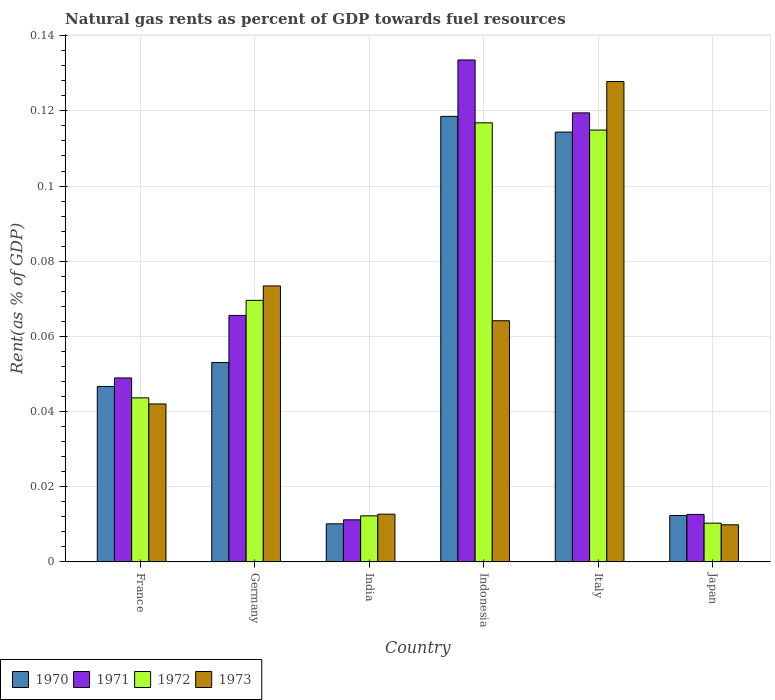How many different coloured bars are there?
Offer a terse response. 4. How many bars are there on the 6th tick from the left?
Your answer should be very brief. 4. How many bars are there on the 3rd tick from the right?
Your answer should be very brief. 4. What is the label of the 6th group of bars from the left?
Your answer should be compact. Japan. In how many cases, is the number of bars for a given country not equal to the number of legend labels?
Give a very brief answer. 0. What is the matural gas rent in 1970 in Germany?
Offer a very short reply. 0.05. Across all countries, what is the maximum matural gas rent in 1972?
Provide a succinct answer. 0.12. Across all countries, what is the minimum matural gas rent in 1971?
Your answer should be very brief. 0.01. What is the total matural gas rent in 1972 in the graph?
Offer a very short reply. 0.37. What is the difference between the matural gas rent in 1970 in India and that in Indonesia?
Provide a succinct answer. -0.11. What is the difference between the matural gas rent in 1972 in India and the matural gas rent in 1971 in Japan?
Your answer should be very brief. -0. What is the average matural gas rent in 1970 per country?
Your answer should be very brief. 0.06. What is the difference between the matural gas rent of/in 1971 and matural gas rent of/in 1973 in Germany?
Offer a very short reply. -0.01. In how many countries, is the matural gas rent in 1971 greater than 0.096 %?
Provide a succinct answer. 2. What is the ratio of the matural gas rent in 1972 in Germany to that in Italy?
Your answer should be very brief. 0.61. What is the difference between the highest and the second highest matural gas rent in 1971?
Provide a succinct answer. 0.07. What is the difference between the highest and the lowest matural gas rent in 1971?
Ensure brevity in your answer.  0.12. In how many countries, is the matural gas rent in 1972 greater than the average matural gas rent in 1972 taken over all countries?
Your answer should be compact. 3. Is the sum of the matural gas rent in 1970 in France and India greater than the maximum matural gas rent in 1971 across all countries?
Provide a short and direct response. No. What does the 4th bar from the right in India represents?
Make the answer very short. 1970. Is it the case that in every country, the sum of the matural gas rent in 1970 and matural gas rent in 1972 is greater than the matural gas rent in 1973?
Offer a terse response. Yes. How many bars are there?
Your response must be concise. 24. How many legend labels are there?
Your answer should be very brief. 4. How are the legend labels stacked?
Make the answer very short. Horizontal. What is the title of the graph?
Provide a succinct answer. Natural gas rents as percent of GDP towards fuel resources. What is the label or title of the X-axis?
Provide a short and direct response. Country. What is the label or title of the Y-axis?
Your answer should be compact. Rent(as % of GDP). What is the Rent(as % of GDP) of 1970 in France?
Offer a very short reply. 0.05. What is the Rent(as % of GDP) of 1971 in France?
Give a very brief answer. 0.05. What is the Rent(as % of GDP) in 1972 in France?
Keep it short and to the point. 0.04. What is the Rent(as % of GDP) in 1973 in France?
Ensure brevity in your answer.  0.04. What is the Rent(as % of GDP) of 1970 in Germany?
Give a very brief answer. 0.05. What is the Rent(as % of GDP) of 1971 in Germany?
Provide a short and direct response. 0.07. What is the Rent(as % of GDP) in 1972 in Germany?
Give a very brief answer. 0.07. What is the Rent(as % of GDP) in 1973 in Germany?
Offer a very short reply. 0.07. What is the Rent(as % of GDP) of 1970 in India?
Give a very brief answer. 0.01. What is the Rent(as % of GDP) of 1971 in India?
Provide a succinct answer. 0.01. What is the Rent(as % of GDP) in 1972 in India?
Make the answer very short. 0.01. What is the Rent(as % of GDP) in 1973 in India?
Your answer should be compact. 0.01. What is the Rent(as % of GDP) in 1970 in Indonesia?
Ensure brevity in your answer.  0.12. What is the Rent(as % of GDP) of 1971 in Indonesia?
Make the answer very short. 0.13. What is the Rent(as % of GDP) in 1972 in Indonesia?
Offer a very short reply. 0.12. What is the Rent(as % of GDP) of 1973 in Indonesia?
Ensure brevity in your answer.  0.06. What is the Rent(as % of GDP) in 1970 in Italy?
Ensure brevity in your answer.  0.11. What is the Rent(as % of GDP) of 1971 in Italy?
Keep it short and to the point. 0.12. What is the Rent(as % of GDP) in 1972 in Italy?
Provide a short and direct response. 0.11. What is the Rent(as % of GDP) of 1973 in Italy?
Provide a short and direct response. 0.13. What is the Rent(as % of GDP) in 1970 in Japan?
Provide a short and direct response. 0.01. What is the Rent(as % of GDP) in 1971 in Japan?
Make the answer very short. 0.01. What is the Rent(as % of GDP) of 1972 in Japan?
Your answer should be very brief. 0.01. What is the Rent(as % of GDP) in 1973 in Japan?
Your response must be concise. 0.01. Across all countries, what is the maximum Rent(as % of GDP) of 1970?
Provide a short and direct response. 0.12. Across all countries, what is the maximum Rent(as % of GDP) of 1971?
Your response must be concise. 0.13. Across all countries, what is the maximum Rent(as % of GDP) of 1972?
Provide a short and direct response. 0.12. Across all countries, what is the maximum Rent(as % of GDP) of 1973?
Provide a succinct answer. 0.13. Across all countries, what is the minimum Rent(as % of GDP) of 1970?
Ensure brevity in your answer.  0.01. Across all countries, what is the minimum Rent(as % of GDP) of 1971?
Keep it short and to the point. 0.01. Across all countries, what is the minimum Rent(as % of GDP) in 1972?
Keep it short and to the point. 0.01. Across all countries, what is the minimum Rent(as % of GDP) in 1973?
Give a very brief answer. 0.01. What is the total Rent(as % of GDP) in 1970 in the graph?
Your answer should be very brief. 0.36. What is the total Rent(as % of GDP) in 1971 in the graph?
Provide a succinct answer. 0.39. What is the total Rent(as % of GDP) of 1972 in the graph?
Keep it short and to the point. 0.37. What is the total Rent(as % of GDP) in 1973 in the graph?
Provide a short and direct response. 0.33. What is the difference between the Rent(as % of GDP) of 1970 in France and that in Germany?
Keep it short and to the point. -0.01. What is the difference between the Rent(as % of GDP) in 1971 in France and that in Germany?
Give a very brief answer. -0.02. What is the difference between the Rent(as % of GDP) in 1972 in France and that in Germany?
Provide a succinct answer. -0.03. What is the difference between the Rent(as % of GDP) in 1973 in France and that in Germany?
Provide a short and direct response. -0.03. What is the difference between the Rent(as % of GDP) in 1970 in France and that in India?
Your answer should be very brief. 0.04. What is the difference between the Rent(as % of GDP) in 1971 in France and that in India?
Give a very brief answer. 0.04. What is the difference between the Rent(as % of GDP) of 1972 in France and that in India?
Your answer should be compact. 0.03. What is the difference between the Rent(as % of GDP) in 1973 in France and that in India?
Your response must be concise. 0.03. What is the difference between the Rent(as % of GDP) of 1970 in France and that in Indonesia?
Keep it short and to the point. -0.07. What is the difference between the Rent(as % of GDP) in 1971 in France and that in Indonesia?
Offer a very short reply. -0.08. What is the difference between the Rent(as % of GDP) in 1972 in France and that in Indonesia?
Your answer should be very brief. -0.07. What is the difference between the Rent(as % of GDP) of 1973 in France and that in Indonesia?
Offer a very short reply. -0.02. What is the difference between the Rent(as % of GDP) in 1970 in France and that in Italy?
Offer a terse response. -0.07. What is the difference between the Rent(as % of GDP) of 1971 in France and that in Italy?
Ensure brevity in your answer.  -0.07. What is the difference between the Rent(as % of GDP) of 1972 in France and that in Italy?
Keep it short and to the point. -0.07. What is the difference between the Rent(as % of GDP) in 1973 in France and that in Italy?
Keep it short and to the point. -0.09. What is the difference between the Rent(as % of GDP) of 1970 in France and that in Japan?
Your answer should be very brief. 0.03. What is the difference between the Rent(as % of GDP) of 1971 in France and that in Japan?
Your answer should be very brief. 0.04. What is the difference between the Rent(as % of GDP) in 1973 in France and that in Japan?
Offer a terse response. 0.03. What is the difference between the Rent(as % of GDP) in 1970 in Germany and that in India?
Give a very brief answer. 0.04. What is the difference between the Rent(as % of GDP) of 1971 in Germany and that in India?
Provide a succinct answer. 0.05. What is the difference between the Rent(as % of GDP) in 1972 in Germany and that in India?
Keep it short and to the point. 0.06. What is the difference between the Rent(as % of GDP) of 1973 in Germany and that in India?
Keep it short and to the point. 0.06. What is the difference between the Rent(as % of GDP) in 1970 in Germany and that in Indonesia?
Ensure brevity in your answer.  -0.07. What is the difference between the Rent(as % of GDP) of 1971 in Germany and that in Indonesia?
Ensure brevity in your answer.  -0.07. What is the difference between the Rent(as % of GDP) of 1972 in Germany and that in Indonesia?
Offer a terse response. -0.05. What is the difference between the Rent(as % of GDP) in 1973 in Germany and that in Indonesia?
Provide a short and direct response. 0.01. What is the difference between the Rent(as % of GDP) in 1970 in Germany and that in Italy?
Provide a succinct answer. -0.06. What is the difference between the Rent(as % of GDP) of 1971 in Germany and that in Italy?
Offer a very short reply. -0.05. What is the difference between the Rent(as % of GDP) in 1972 in Germany and that in Italy?
Keep it short and to the point. -0.05. What is the difference between the Rent(as % of GDP) of 1973 in Germany and that in Italy?
Make the answer very short. -0.05. What is the difference between the Rent(as % of GDP) in 1970 in Germany and that in Japan?
Provide a succinct answer. 0.04. What is the difference between the Rent(as % of GDP) in 1971 in Germany and that in Japan?
Your answer should be very brief. 0.05. What is the difference between the Rent(as % of GDP) in 1972 in Germany and that in Japan?
Ensure brevity in your answer.  0.06. What is the difference between the Rent(as % of GDP) in 1973 in Germany and that in Japan?
Provide a short and direct response. 0.06. What is the difference between the Rent(as % of GDP) of 1970 in India and that in Indonesia?
Make the answer very short. -0.11. What is the difference between the Rent(as % of GDP) of 1971 in India and that in Indonesia?
Ensure brevity in your answer.  -0.12. What is the difference between the Rent(as % of GDP) of 1972 in India and that in Indonesia?
Keep it short and to the point. -0.1. What is the difference between the Rent(as % of GDP) in 1973 in India and that in Indonesia?
Ensure brevity in your answer.  -0.05. What is the difference between the Rent(as % of GDP) of 1970 in India and that in Italy?
Your response must be concise. -0.1. What is the difference between the Rent(as % of GDP) of 1971 in India and that in Italy?
Keep it short and to the point. -0.11. What is the difference between the Rent(as % of GDP) in 1972 in India and that in Italy?
Offer a very short reply. -0.1. What is the difference between the Rent(as % of GDP) in 1973 in India and that in Italy?
Your response must be concise. -0.12. What is the difference between the Rent(as % of GDP) in 1970 in India and that in Japan?
Your answer should be compact. -0. What is the difference between the Rent(as % of GDP) of 1971 in India and that in Japan?
Provide a short and direct response. -0. What is the difference between the Rent(as % of GDP) of 1972 in India and that in Japan?
Your answer should be compact. 0. What is the difference between the Rent(as % of GDP) of 1973 in India and that in Japan?
Make the answer very short. 0. What is the difference between the Rent(as % of GDP) of 1970 in Indonesia and that in Italy?
Keep it short and to the point. 0. What is the difference between the Rent(as % of GDP) of 1971 in Indonesia and that in Italy?
Your response must be concise. 0.01. What is the difference between the Rent(as % of GDP) of 1972 in Indonesia and that in Italy?
Ensure brevity in your answer.  0. What is the difference between the Rent(as % of GDP) in 1973 in Indonesia and that in Italy?
Give a very brief answer. -0.06. What is the difference between the Rent(as % of GDP) in 1970 in Indonesia and that in Japan?
Your answer should be very brief. 0.11. What is the difference between the Rent(as % of GDP) in 1971 in Indonesia and that in Japan?
Ensure brevity in your answer.  0.12. What is the difference between the Rent(as % of GDP) of 1972 in Indonesia and that in Japan?
Offer a very short reply. 0.11. What is the difference between the Rent(as % of GDP) in 1973 in Indonesia and that in Japan?
Give a very brief answer. 0.05. What is the difference between the Rent(as % of GDP) in 1970 in Italy and that in Japan?
Ensure brevity in your answer.  0.1. What is the difference between the Rent(as % of GDP) in 1971 in Italy and that in Japan?
Ensure brevity in your answer.  0.11. What is the difference between the Rent(as % of GDP) in 1972 in Italy and that in Japan?
Ensure brevity in your answer.  0.1. What is the difference between the Rent(as % of GDP) in 1973 in Italy and that in Japan?
Keep it short and to the point. 0.12. What is the difference between the Rent(as % of GDP) in 1970 in France and the Rent(as % of GDP) in 1971 in Germany?
Ensure brevity in your answer.  -0.02. What is the difference between the Rent(as % of GDP) of 1970 in France and the Rent(as % of GDP) of 1972 in Germany?
Ensure brevity in your answer.  -0.02. What is the difference between the Rent(as % of GDP) of 1970 in France and the Rent(as % of GDP) of 1973 in Germany?
Your answer should be compact. -0.03. What is the difference between the Rent(as % of GDP) of 1971 in France and the Rent(as % of GDP) of 1972 in Germany?
Give a very brief answer. -0.02. What is the difference between the Rent(as % of GDP) in 1971 in France and the Rent(as % of GDP) in 1973 in Germany?
Keep it short and to the point. -0.02. What is the difference between the Rent(as % of GDP) of 1972 in France and the Rent(as % of GDP) of 1973 in Germany?
Offer a terse response. -0.03. What is the difference between the Rent(as % of GDP) of 1970 in France and the Rent(as % of GDP) of 1971 in India?
Keep it short and to the point. 0.04. What is the difference between the Rent(as % of GDP) in 1970 in France and the Rent(as % of GDP) in 1972 in India?
Give a very brief answer. 0.03. What is the difference between the Rent(as % of GDP) in 1970 in France and the Rent(as % of GDP) in 1973 in India?
Your response must be concise. 0.03. What is the difference between the Rent(as % of GDP) in 1971 in France and the Rent(as % of GDP) in 1972 in India?
Your response must be concise. 0.04. What is the difference between the Rent(as % of GDP) in 1971 in France and the Rent(as % of GDP) in 1973 in India?
Make the answer very short. 0.04. What is the difference between the Rent(as % of GDP) of 1972 in France and the Rent(as % of GDP) of 1973 in India?
Offer a terse response. 0.03. What is the difference between the Rent(as % of GDP) in 1970 in France and the Rent(as % of GDP) in 1971 in Indonesia?
Make the answer very short. -0.09. What is the difference between the Rent(as % of GDP) in 1970 in France and the Rent(as % of GDP) in 1972 in Indonesia?
Offer a terse response. -0.07. What is the difference between the Rent(as % of GDP) of 1970 in France and the Rent(as % of GDP) of 1973 in Indonesia?
Offer a very short reply. -0.02. What is the difference between the Rent(as % of GDP) of 1971 in France and the Rent(as % of GDP) of 1972 in Indonesia?
Provide a succinct answer. -0.07. What is the difference between the Rent(as % of GDP) in 1971 in France and the Rent(as % of GDP) in 1973 in Indonesia?
Offer a very short reply. -0.02. What is the difference between the Rent(as % of GDP) in 1972 in France and the Rent(as % of GDP) in 1973 in Indonesia?
Give a very brief answer. -0.02. What is the difference between the Rent(as % of GDP) in 1970 in France and the Rent(as % of GDP) in 1971 in Italy?
Give a very brief answer. -0.07. What is the difference between the Rent(as % of GDP) in 1970 in France and the Rent(as % of GDP) in 1972 in Italy?
Give a very brief answer. -0.07. What is the difference between the Rent(as % of GDP) in 1970 in France and the Rent(as % of GDP) in 1973 in Italy?
Offer a terse response. -0.08. What is the difference between the Rent(as % of GDP) in 1971 in France and the Rent(as % of GDP) in 1972 in Italy?
Make the answer very short. -0.07. What is the difference between the Rent(as % of GDP) of 1971 in France and the Rent(as % of GDP) of 1973 in Italy?
Ensure brevity in your answer.  -0.08. What is the difference between the Rent(as % of GDP) of 1972 in France and the Rent(as % of GDP) of 1973 in Italy?
Provide a short and direct response. -0.08. What is the difference between the Rent(as % of GDP) in 1970 in France and the Rent(as % of GDP) in 1971 in Japan?
Your answer should be compact. 0.03. What is the difference between the Rent(as % of GDP) of 1970 in France and the Rent(as % of GDP) of 1972 in Japan?
Offer a terse response. 0.04. What is the difference between the Rent(as % of GDP) in 1970 in France and the Rent(as % of GDP) in 1973 in Japan?
Provide a short and direct response. 0.04. What is the difference between the Rent(as % of GDP) of 1971 in France and the Rent(as % of GDP) of 1972 in Japan?
Offer a terse response. 0.04. What is the difference between the Rent(as % of GDP) of 1971 in France and the Rent(as % of GDP) of 1973 in Japan?
Provide a succinct answer. 0.04. What is the difference between the Rent(as % of GDP) in 1972 in France and the Rent(as % of GDP) in 1973 in Japan?
Your answer should be compact. 0.03. What is the difference between the Rent(as % of GDP) of 1970 in Germany and the Rent(as % of GDP) of 1971 in India?
Your answer should be very brief. 0.04. What is the difference between the Rent(as % of GDP) of 1970 in Germany and the Rent(as % of GDP) of 1972 in India?
Offer a very short reply. 0.04. What is the difference between the Rent(as % of GDP) of 1970 in Germany and the Rent(as % of GDP) of 1973 in India?
Offer a terse response. 0.04. What is the difference between the Rent(as % of GDP) in 1971 in Germany and the Rent(as % of GDP) in 1972 in India?
Your answer should be compact. 0.05. What is the difference between the Rent(as % of GDP) in 1971 in Germany and the Rent(as % of GDP) in 1973 in India?
Ensure brevity in your answer.  0.05. What is the difference between the Rent(as % of GDP) in 1972 in Germany and the Rent(as % of GDP) in 1973 in India?
Give a very brief answer. 0.06. What is the difference between the Rent(as % of GDP) of 1970 in Germany and the Rent(as % of GDP) of 1971 in Indonesia?
Your answer should be very brief. -0.08. What is the difference between the Rent(as % of GDP) of 1970 in Germany and the Rent(as % of GDP) of 1972 in Indonesia?
Your answer should be very brief. -0.06. What is the difference between the Rent(as % of GDP) in 1970 in Germany and the Rent(as % of GDP) in 1973 in Indonesia?
Your answer should be very brief. -0.01. What is the difference between the Rent(as % of GDP) in 1971 in Germany and the Rent(as % of GDP) in 1972 in Indonesia?
Your response must be concise. -0.05. What is the difference between the Rent(as % of GDP) of 1971 in Germany and the Rent(as % of GDP) of 1973 in Indonesia?
Make the answer very short. 0. What is the difference between the Rent(as % of GDP) in 1972 in Germany and the Rent(as % of GDP) in 1973 in Indonesia?
Provide a succinct answer. 0.01. What is the difference between the Rent(as % of GDP) of 1970 in Germany and the Rent(as % of GDP) of 1971 in Italy?
Offer a very short reply. -0.07. What is the difference between the Rent(as % of GDP) of 1970 in Germany and the Rent(as % of GDP) of 1972 in Italy?
Provide a succinct answer. -0.06. What is the difference between the Rent(as % of GDP) in 1970 in Germany and the Rent(as % of GDP) in 1973 in Italy?
Offer a terse response. -0.07. What is the difference between the Rent(as % of GDP) of 1971 in Germany and the Rent(as % of GDP) of 1972 in Italy?
Provide a succinct answer. -0.05. What is the difference between the Rent(as % of GDP) in 1971 in Germany and the Rent(as % of GDP) in 1973 in Italy?
Give a very brief answer. -0.06. What is the difference between the Rent(as % of GDP) in 1972 in Germany and the Rent(as % of GDP) in 1973 in Italy?
Keep it short and to the point. -0.06. What is the difference between the Rent(as % of GDP) in 1970 in Germany and the Rent(as % of GDP) in 1971 in Japan?
Your answer should be compact. 0.04. What is the difference between the Rent(as % of GDP) of 1970 in Germany and the Rent(as % of GDP) of 1972 in Japan?
Offer a very short reply. 0.04. What is the difference between the Rent(as % of GDP) in 1970 in Germany and the Rent(as % of GDP) in 1973 in Japan?
Provide a short and direct response. 0.04. What is the difference between the Rent(as % of GDP) of 1971 in Germany and the Rent(as % of GDP) of 1972 in Japan?
Your response must be concise. 0.06. What is the difference between the Rent(as % of GDP) in 1971 in Germany and the Rent(as % of GDP) in 1973 in Japan?
Keep it short and to the point. 0.06. What is the difference between the Rent(as % of GDP) in 1972 in Germany and the Rent(as % of GDP) in 1973 in Japan?
Offer a very short reply. 0.06. What is the difference between the Rent(as % of GDP) of 1970 in India and the Rent(as % of GDP) of 1971 in Indonesia?
Keep it short and to the point. -0.12. What is the difference between the Rent(as % of GDP) in 1970 in India and the Rent(as % of GDP) in 1972 in Indonesia?
Your response must be concise. -0.11. What is the difference between the Rent(as % of GDP) of 1970 in India and the Rent(as % of GDP) of 1973 in Indonesia?
Ensure brevity in your answer.  -0.05. What is the difference between the Rent(as % of GDP) in 1971 in India and the Rent(as % of GDP) in 1972 in Indonesia?
Provide a succinct answer. -0.11. What is the difference between the Rent(as % of GDP) of 1971 in India and the Rent(as % of GDP) of 1973 in Indonesia?
Your answer should be very brief. -0.05. What is the difference between the Rent(as % of GDP) in 1972 in India and the Rent(as % of GDP) in 1973 in Indonesia?
Offer a terse response. -0.05. What is the difference between the Rent(as % of GDP) of 1970 in India and the Rent(as % of GDP) of 1971 in Italy?
Keep it short and to the point. -0.11. What is the difference between the Rent(as % of GDP) in 1970 in India and the Rent(as % of GDP) in 1972 in Italy?
Make the answer very short. -0.1. What is the difference between the Rent(as % of GDP) of 1970 in India and the Rent(as % of GDP) of 1973 in Italy?
Offer a very short reply. -0.12. What is the difference between the Rent(as % of GDP) in 1971 in India and the Rent(as % of GDP) in 1972 in Italy?
Your answer should be compact. -0.1. What is the difference between the Rent(as % of GDP) of 1971 in India and the Rent(as % of GDP) of 1973 in Italy?
Make the answer very short. -0.12. What is the difference between the Rent(as % of GDP) in 1972 in India and the Rent(as % of GDP) in 1973 in Italy?
Your answer should be very brief. -0.12. What is the difference between the Rent(as % of GDP) in 1970 in India and the Rent(as % of GDP) in 1971 in Japan?
Provide a succinct answer. -0. What is the difference between the Rent(as % of GDP) in 1970 in India and the Rent(as % of GDP) in 1972 in Japan?
Give a very brief answer. -0. What is the difference between the Rent(as % of GDP) of 1970 in India and the Rent(as % of GDP) of 1973 in Japan?
Provide a short and direct response. 0. What is the difference between the Rent(as % of GDP) in 1971 in India and the Rent(as % of GDP) in 1972 in Japan?
Your response must be concise. 0. What is the difference between the Rent(as % of GDP) of 1971 in India and the Rent(as % of GDP) of 1973 in Japan?
Offer a very short reply. 0. What is the difference between the Rent(as % of GDP) in 1972 in India and the Rent(as % of GDP) in 1973 in Japan?
Offer a terse response. 0. What is the difference between the Rent(as % of GDP) in 1970 in Indonesia and the Rent(as % of GDP) in 1971 in Italy?
Your response must be concise. -0. What is the difference between the Rent(as % of GDP) of 1970 in Indonesia and the Rent(as % of GDP) of 1972 in Italy?
Provide a succinct answer. 0. What is the difference between the Rent(as % of GDP) in 1970 in Indonesia and the Rent(as % of GDP) in 1973 in Italy?
Offer a very short reply. -0.01. What is the difference between the Rent(as % of GDP) in 1971 in Indonesia and the Rent(as % of GDP) in 1972 in Italy?
Keep it short and to the point. 0.02. What is the difference between the Rent(as % of GDP) of 1971 in Indonesia and the Rent(as % of GDP) of 1973 in Italy?
Your response must be concise. 0.01. What is the difference between the Rent(as % of GDP) of 1972 in Indonesia and the Rent(as % of GDP) of 1973 in Italy?
Provide a succinct answer. -0.01. What is the difference between the Rent(as % of GDP) of 1970 in Indonesia and the Rent(as % of GDP) of 1971 in Japan?
Provide a short and direct response. 0.11. What is the difference between the Rent(as % of GDP) of 1970 in Indonesia and the Rent(as % of GDP) of 1972 in Japan?
Offer a very short reply. 0.11. What is the difference between the Rent(as % of GDP) in 1970 in Indonesia and the Rent(as % of GDP) in 1973 in Japan?
Offer a terse response. 0.11. What is the difference between the Rent(as % of GDP) in 1971 in Indonesia and the Rent(as % of GDP) in 1972 in Japan?
Provide a short and direct response. 0.12. What is the difference between the Rent(as % of GDP) in 1971 in Indonesia and the Rent(as % of GDP) in 1973 in Japan?
Your response must be concise. 0.12. What is the difference between the Rent(as % of GDP) in 1972 in Indonesia and the Rent(as % of GDP) in 1973 in Japan?
Offer a very short reply. 0.11. What is the difference between the Rent(as % of GDP) in 1970 in Italy and the Rent(as % of GDP) in 1971 in Japan?
Keep it short and to the point. 0.1. What is the difference between the Rent(as % of GDP) in 1970 in Italy and the Rent(as % of GDP) in 1972 in Japan?
Make the answer very short. 0.1. What is the difference between the Rent(as % of GDP) of 1970 in Italy and the Rent(as % of GDP) of 1973 in Japan?
Make the answer very short. 0.1. What is the difference between the Rent(as % of GDP) in 1971 in Italy and the Rent(as % of GDP) in 1972 in Japan?
Offer a very short reply. 0.11. What is the difference between the Rent(as % of GDP) of 1971 in Italy and the Rent(as % of GDP) of 1973 in Japan?
Ensure brevity in your answer.  0.11. What is the difference between the Rent(as % of GDP) of 1972 in Italy and the Rent(as % of GDP) of 1973 in Japan?
Make the answer very short. 0.1. What is the average Rent(as % of GDP) of 1970 per country?
Keep it short and to the point. 0.06. What is the average Rent(as % of GDP) in 1971 per country?
Offer a very short reply. 0.07. What is the average Rent(as % of GDP) of 1972 per country?
Provide a short and direct response. 0.06. What is the average Rent(as % of GDP) of 1973 per country?
Provide a short and direct response. 0.06. What is the difference between the Rent(as % of GDP) in 1970 and Rent(as % of GDP) in 1971 in France?
Keep it short and to the point. -0. What is the difference between the Rent(as % of GDP) in 1970 and Rent(as % of GDP) in 1972 in France?
Provide a short and direct response. 0. What is the difference between the Rent(as % of GDP) of 1970 and Rent(as % of GDP) of 1973 in France?
Your answer should be very brief. 0. What is the difference between the Rent(as % of GDP) of 1971 and Rent(as % of GDP) of 1972 in France?
Offer a terse response. 0.01. What is the difference between the Rent(as % of GDP) in 1971 and Rent(as % of GDP) in 1973 in France?
Your answer should be very brief. 0.01. What is the difference between the Rent(as % of GDP) of 1972 and Rent(as % of GDP) of 1973 in France?
Ensure brevity in your answer.  0. What is the difference between the Rent(as % of GDP) of 1970 and Rent(as % of GDP) of 1971 in Germany?
Ensure brevity in your answer.  -0.01. What is the difference between the Rent(as % of GDP) of 1970 and Rent(as % of GDP) of 1972 in Germany?
Offer a very short reply. -0.02. What is the difference between the Rent(as % of GDP) of 1970 and Rent(as % of GDP) of 1973 in Germany?
Offer a terse response. -0.02. What is the difference between the Rent(as % of GDP) of 1971 and Rent(as % of GDP) of 1972 in Germany?
Keep it short and to the point. -0. What is the difference between the Rent(as % of GDP) of 1971 and Rent(as % of GDP) of 1973 in Germany?
Offer a very short reply. -0.01. What is the difference between the Rent(as % of GDP) in 1972 and Rent(as % of GDP) in 1973 in Germany?
Your answer should be compact. -0. What is the difference between the Rent(as % of GDP) of 1970 and Rent(as % of GDP) of 1971 in India?
Provide a short and direct response. -0. What is the difference between the Rent(as % of GDP) of 1970 and Rent(as % of GDP) of 1972 in India?
Offer a very short reply. -0. What is the difference between the Rent(as % of GDP) of 1970 and Rent(as % of GDP) of 1973 in India?
Provide a short and direct response. -0. What is the difference between the Rent(as % of GDP) in 1971 and Rent(as % of GDP) in 1972 in India?
Your answer should be compact. -0. What is the difference between the Rent(as % of GDP) of 1971 and Rent(as % of GDP) of 1973 in India?
Your answer should be very brief. -0. What is the difference between the Rent(as % of GDP) in 1972 and Rent(as % of GDP) in 1973 in India?
Offer a terse response. -0. What is the difference between the Rent(as % of GDP) of 1970 and Rent(as % of GDP) of 1971 in Indonesia?
Your answer should be compact. -0.01. What is the difference between the Rent(as % of GDP) of 1970 and Rent(as % of GDP) of 1972 in Indonesia?
Give a very brief answer. 0. What is the difference between the Rent(as % of GDP) of 1970 and Rent(as % of GDP) of 1973 in Indonesia?
Make the answer very short. 0.05. What is the difference between the Rent(as % of GDP) of 1971 and Rent(as % of GDP) of 1972 in Indonesia?
Your response must be concise. 0.02. What is the difference between the Rent(as % of GDP) in 1971 and Rent(as % of GDP) in 1973 in Indonesia?
Your answer should be very brief. 0.07. What is the difference between the Rent(as % of GDP) of 1972 and Rent(as % of GDP) of 1973 in Indonesia?
Your answer should be compact. 0.05. What is the difference between the Rent(as % of GDP) of 1970 and Rent(as % of GDP) of 1971 in Italy?
Keep it short and to the point. -0.01. What is the difference between the Rent(as % of GDP) of 1970 and Rent(as % of GDP) of 1972 in Italy?
Provide a succinct answer. -0. What is the difference between the Rent(as % of GDP) in 1970 and Rent(as % of GDP) in 1973 in Italy?
Offer a very short reply. -0.01. What is the difference between the Rent(as % of GDP) in 1971 and Rent(as % of GDP) in 1972 in Italy?
Your response must be concise. 0. What is the difference between the Rent(as % of GDP) in 1971 and Rent(as % of GDP) in 1973 in Italy?
Provide a succinct answer. -0.01. What is the difference between the Rent(as % of GDP) in 1972 and Rent(as % of GDP) in 1973 in Italy?
Your answer should be compact. -0.01. What is the difference between the Rent(as % of GDP) in 1970 and Rent(as % of GDP) in 1971 in Japan?
Ensure brevity in your answer.  -0. What is the difference between the Rent(as % of GDP) in 1970 and Rent(as % of GDP) in 1972 in Japan?
Provide a succinct answer. 0. What is the difference between the Rent(as % of GDP) in 1970 and Rent(as % of GDP) in 1973 in Japan?
Give a very brief answer. 0. What is the difference between the Rent(as % of GDP) of 1971 and Rent(as % of GDP) of 1972 in Japan?
Your answer should be compact. 0. What is the difference between the Rent(as % of GDP) of 1971 and Rent(as % of GDP) of 1973 in Japan?
Give a very brief answer. 0. What is the difference between the Rent(as % of GDP) in 1972 and Rent(as % of GDP) in 1973 in Japan?
Make the answer very short. 0. What is the ratio of the Rent(as % of GDP) in 1970 in France to that in Germany?
Keep it short and to the point. 0.88. What is the ratio of the Rent(as % of GDP) of 1971 in France to that in Germany?
Make the answer very short. 0.75. What is the ratio of the Rent(as % of GDP) in 1972 in France to that in Germany?
Make the answer very short. 0.63. What is the ratio of the Rent(as % of GDP) of 1973 in France to that in Germany?
Ensure brevity in your answer.  0.57. What is the ratio of the Rent(as % of GDP) in 1970 in France to that in India?
Keep it short and to the point. 4.61. What is the ratio of the Rent(as % of GDP) in 1971 in France to that in India?
Offer a terse response. 4.37. What is the ratio of the Rent(as % of GDP) in 1972 in France to that in India?
Your answer should be compact. 3.56. What is the ratio of the Rent(as % of GDP) in 1973 in France to that in India?
Offer a very short reply. 3.31. What is the ratio of the Rent(as % of GDP) in 1970 in France to that in Indonesia?
Give a very brief answer. 0.39. What is the ratio of the Rent(as % of GDP) in 1971 in France to that in Indonesia?
Give a very brief answer. 0.37. What is the ratio of the Rent(as % of GDP) in 1972 in France to that in Indonesia?
Your response must be concise. 0.37. What is the ratio of the Rent(as % of GDP) in 1973 in France to that in Indonesia?
Your response must be concise. 0.65. What is the ratio of the Rent(as % of GDP) in 1970 in France to that in Italy?
Keep it short and to the point. 0.41. What is the ratio of the Rent(as % of GDP) of 1971 in France to that in Italy?
Ensure brevity in your answer.  0.41. What is the ratio of the Rent(as % of GDP) of 1972 in France to that in Italy?
Provide a succinct answer. 0.38. What is the ratio of the Rent(as % of GDP) in 1973 in France to that in Italy?
Provide a short and direct response. 0.33. What is the ratio of the Rent(as % of GDP) of 1970 in France to that in Japan?
Offer a very short reply. 3.78. What is the ratio of the Rent(as % of GDP) in 1971 in France to that in Japan?
Your answer should be very brief. 3.88. What is the ratio of the Rent(as % of GDP) in 1972 in France to that in Japan?
Offer a very short reply. 4.24. What is the ratio of the Rent(as % of GDP) of 1973 in France to that in Japan?
Provide a short and direct response. 4.26. What is the ratio of the Rent(as % of GDP) in 1970 in Germany to that in India?
Offer a terse response. 5.24. What is the ratio of the Rent(as % of GDP) in 1971 in Germany to that in India?
Your answer should be compact. 5.86. What is the ratio of the Rent(as % of GDP) of 1972 in Germany to that in India?
Your response must be concise. 5.68. What is the ratio of the Rent(as % of GDP) in 1973 in Germany to that in India?
Offer a very short reply. 5.79. What is the ratio of the Rent(as % of GDP) of 1970 in Germany to that in Indonesia?
Your response must be concise. 0.45. What is the ratio of the Rent(as % of GDP) of 1971 in Germany to that in Indonesia?
Your response must be concise. 0.49. What is the ratio of the Rent(as % of GDP) in 1972 in Germany to that in Indonesia?
Your answer should be very brief. 0.6. What is the ratio of the Rent(as % of GDP) in 1973 in Germany to that in Indonesia?
Make the answer very short. 1.14. What is the ratio of the Rent(as % of GDP) of 1970 in Germany to that in Italy?
Offer a very short reply. 0.46. What is the ratio of the Rent(as % of GDP) of 1971 in Germany to that in Italy?
Offer a very short reply. 0.55. What is the ratio of the Rent(as % of GDP) of 1972 in Germany to that in Italy?
Offer a terse response. 0.61. What is the ratio of the Rent(as % of GDP) in 1973 in Germany to that in Italy?
Your answer should be very brief. 0.57. What is the ratio of the Rent(as % of GDP) in 1970 in Germany to that in Japan?
Ensure brevity in your answer.  4.3. What is the ratio of the Rent(as % of GDP) of 1971 in Germany to that in Japan?
Keep it short and to the point. 5.19. What is the ratio of the Rent(as % of GDP) of 1972 in Germany to that in Japan?
Provide a short and direct response. 6.76. What is the ratio of the Rent(as % of GDP) in 1973 in Germany to that in Japan?
Offer a very short reply. 7.44. What is the ratio of the Rent(as % of GDP) in 1970 in India to that in Indonesia?
Offer a terse response. 0.09. What is the ratio of the Rent(as % of GDP) of 1971 in India to that in Indonesia?
Your response must be concise. 0.08. What is the ratio of the Rent(as % of GDP) in 1972 in India to that in Indonesia?
Offer a very short reply. 0.1. What is the ratio of the Rent(as % of GDP) in 1973 in India to that in Indonesia?
Offer a very short reply. 0.2. What is the ratio of the Rent(as % of GDP) of 1970 in India to that in Italy?
Offer a very short reply. 0.09. What is the ratio of the Rent(as % of GDP) of 1971 in India to that in Italy?
Make the answer very short. 0.09. What is the ratio of the Rent(as % of GDP) of 1972 in India to that in Italy?
Ensure brevity in your answer.  0.11. What is the ratio of the Rent(as % of GDP) in 1973 in India to that in Italy?
Your response must be concise. 0.1. What is the ratio of the Rent(as % of GDP) in 1970 in India to that in Japan?
Give a very brief answer. 0.82. What is the ratio of the Rent(as % of GDP) in 1971 in India to that in Japan?
Provide a succinct answer. 0.89. What is the ratio of the Rent(as % of GDP) in 1972 in India to that in Japan?
Your response must be concise. 1.19. What is the ratio of the Rent(as % of GDP) in 1973 in India to that in Japan?
Make the answer very short. 1.29. What is the ratio of the Rent(as % of GDP) in 1970 in Indonesia to that in Italy?
Provide a succinct answer. 1.04. What is the ratio of the Rent(as % of GDP) of 1971 in Indonesia to that in Italy?
Your answer should be compact. 1.12. What is the ratio of the Rent(as % of GDP) in 1972 in Indonesia to that in Italy?
Ensure brevity in your answer.  1.02. What is the ratio of the Rent(as % of GDP) in 1973 in Indonesia to that in Italy?
Keep it short and to the point. 0.5. What is the ratio of the Rent(as % of GDP) of 1970 in Indonesia to that in Japan?
Provide a short and direct response. 9.61. What is the ratio of the Rent(as % of GDP) of 1971 in Indonesia to that in Japan?
Give a very brief answer. 10.58. What is the ratio of the Rent(as % of GDP) in 1972 in Indonesia to that in Japan?
Give a very brief answer. 11.34. What is the ratio of the Rent(as % of GDP) in 1973 in Indonesia to that in Japan?
Ensure brevity in your answer.  6.5. What is the ratio of the Rent(as % of GDP) of 1970 in Italy to that in Japan?
Provide a short and direct response. 9.27. What is the ratio of the Rent(as % of GDP) of 1971 in Italy to that in Japan?
Your answer should be very brief. 9.46. What is the ratio of the Rent(as % of GDP) of 1972 in Italy to that in Japan?
Offer a terse response. 11.16. What is the ratio of the Rent(as % of GDP) of 1973 in Italy to that in Japan?
Provide a succinct answer. 12.96. What is the difference between the highest and the second highest Rent(as % of GDP) of 1970?
Offer a very short reply. 0. What is the difference between the highest and the second highest Rent(as % of GDP) in 1971?
Provide a short and direct response. 0.01. What is the difference between the highest and the second highest Rent(as % of GDP) of 1972?
Your answer should be compact. 0. What is the difference between the highest and the second highest Rent(as % of GDP) in 1973?
Offer a very short reply. 0.05. What is the difference between the highest and the lowest Rent(as % of GDP) of 1970?
Offer a very short reply. 0.11. What is the difference between the highest and the lowest Rent(as % of GDP) of 1971?
Make the answer very short. 0.12. What is the difference between the highest and the lowest Rent(as % of GDP) in 1972?
Your answer should be very brief. 0.11. What is the difference between the highest and the lowest Rent(as % of GDP) of 1973?
Make the answer very short. 0.12. 